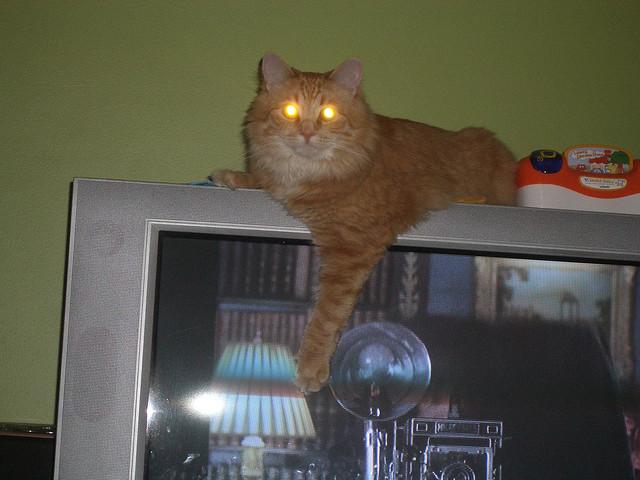Is the TV on?
Write a very short answer. Yes. Does the cat have its brights on?
Keep it brief. No. What is the cat lying on?
Quick response, please. Tv. 